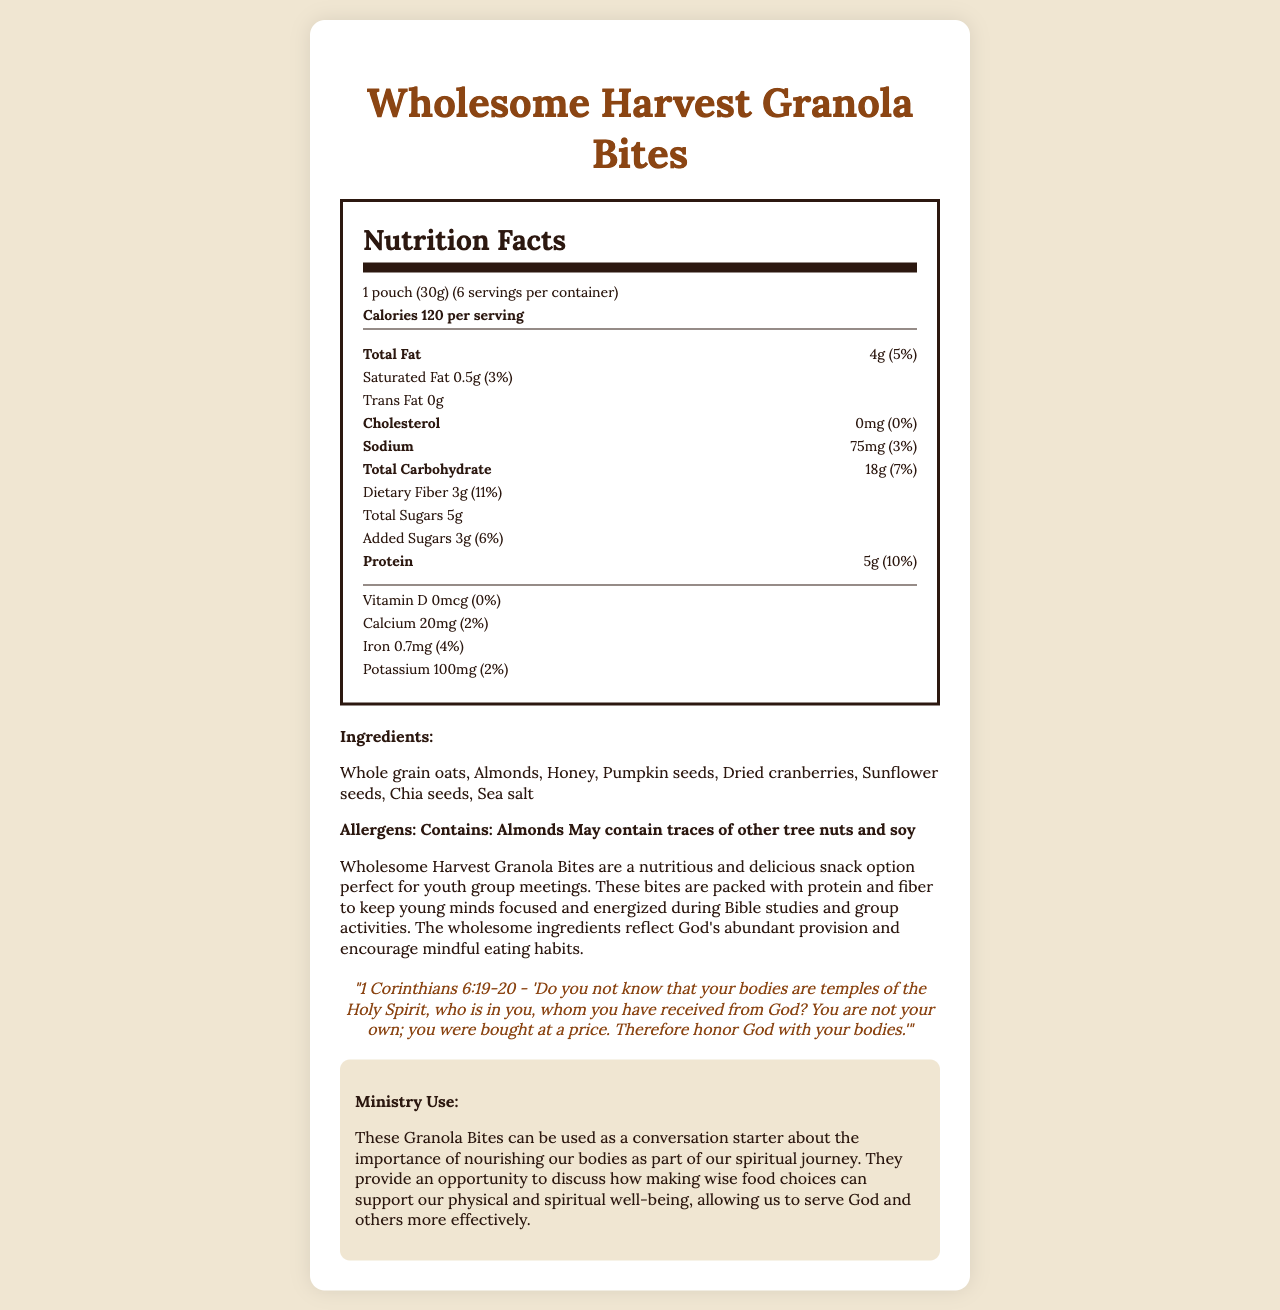what is the serving size for Wholesome Harvest Granola Bites? The serving size is listed at the beginning of the nutrition facts section.
Answer: 1 pouch (30g) how much protein is in each serving? The amount of protein per serving is specified in the nutrition information.
Answer: 5g what percentage of dietary fiber does one serving provide? The document indicates that one serving contains 3g of dietary fiber, which is 11% of the daily value.
Answer: 11% how many servings are in each container? The nutrition facts section shows there are 6 servings per container.
Answer: 6 what is the total fat content per serving? The total fat content per serving is given in the nutrition facts.
Answer: 4g what is the main purpose of Wholesome Harvest Granola Bites, according to the document? The product description mentions it as a nutritious and delicious snack option perfect for youth group meetings.
Answer: A snack option for youth group meetings which ingredient is a potential allergen? A) Honey B) Almonds C) Chia seeds D) Pumpkin seeds The document lists almonds as an allergen.
Answer: B) Almonds what verse is mentioned for the biblical tie in the document? A) John 3:16 B) Psalm 23:1 C) 1 Corinthians 6:19-20 D) Genesis 1:29 The biblical tie section specifies 1 Corinthians 6:19-20.
Answer: C) 1 Corinthians 6:19-20 are there any added sugars in each serving? The nutrition facts indicate that there are 3g of added sugars per serving.
Answer: Yes is this snack option good for discussing physical and spiritual well-being? The ministry use section mentions using the granola bites to discuss physical and spiritual well-being.
Answer: Yes describe the main idea of the document. The document is informative about the product's nutritional benefits, intended use for youth groups, and incorporation of a biblically inspired message about healthy living.
Answer: The Wholesome Harvest Granola Bites document provides detailed information about the nutritional content, ingredients, potential allergens, and uses of the product. It emphasizes the high protein and fiber content, making it suitable for youth group meetings. The document also ties in a biblical reference to highlight the importance of nourishing our bodies. what is the main source of protein in the granola bites? The exact main source of protein is not specified in the document. It lists several ingredients that could contribute to protein content, such as almonds, pumpkin seeds, and chia seeds.
Answer: Cannot be determined what percentage of sodium does one serving provide? The nutrition facts section specifies that one serving provides 75mg of sodium, which is 3% of the daily value.
Answer: 3% 